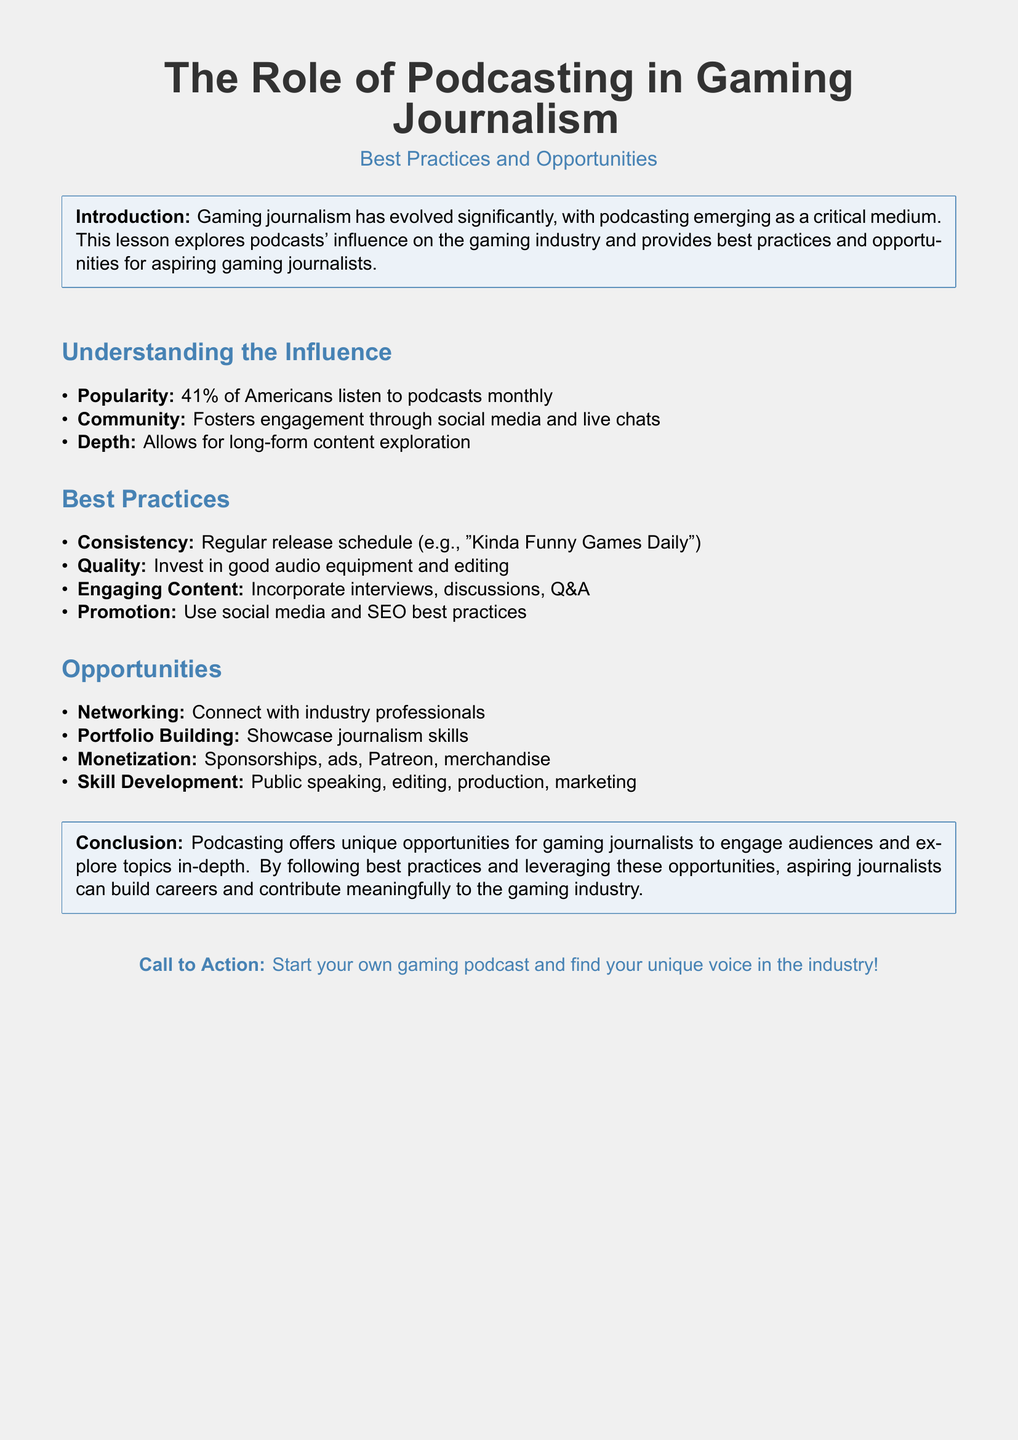What percentage of Americans listen to podcasts monthly? The document states that 41% of Americans listen to podcasts monthly.
Answer: 41% What is one key factor for successful podcasting mentioned in the best practices? The best practices section mentions consistency in the release schedule as a key factor.
Answer: Consistency What type of content should be incorporated according to best practices? Engaging content such as interviews and discussions should be incorporated as per the best practices outlined.
Answer: Interviews, discussions What opportunity is mentioned for building connections in the gaming industry? The document mentions networking as an opportunity for connecting with industry professionals.
Answer: Networking What is a potential source of income for gaming podcasters mentioned? The document lists sponsorships as a potential source of income for gaming podcasters.
Answer: Sponsorships What is the document's conclusion about podcasting? The conclusion highlights that podcasting offers unique opportunities for gaming journalists to engage audiences and explore topics.
Answer: Unique opportunities What should aspiring journalists do to find their unique voice in the industry? The call to action encourages aspiring journalists to start their own gaming podcast to find their unique voice.
Answer: Start your own gaming podcast What medium is emphasized as critical in gaming journalism? The introduction states that podcasting has emerged as a critical medium in gaming journalism.
Answer: Podcasting What skill development opportunities are listed for aspiring gaming journalists? The document mentions public speaking, editing, production, and marketing as skill development opportunities.
Answer: Public speaking, editing, production, marketing 